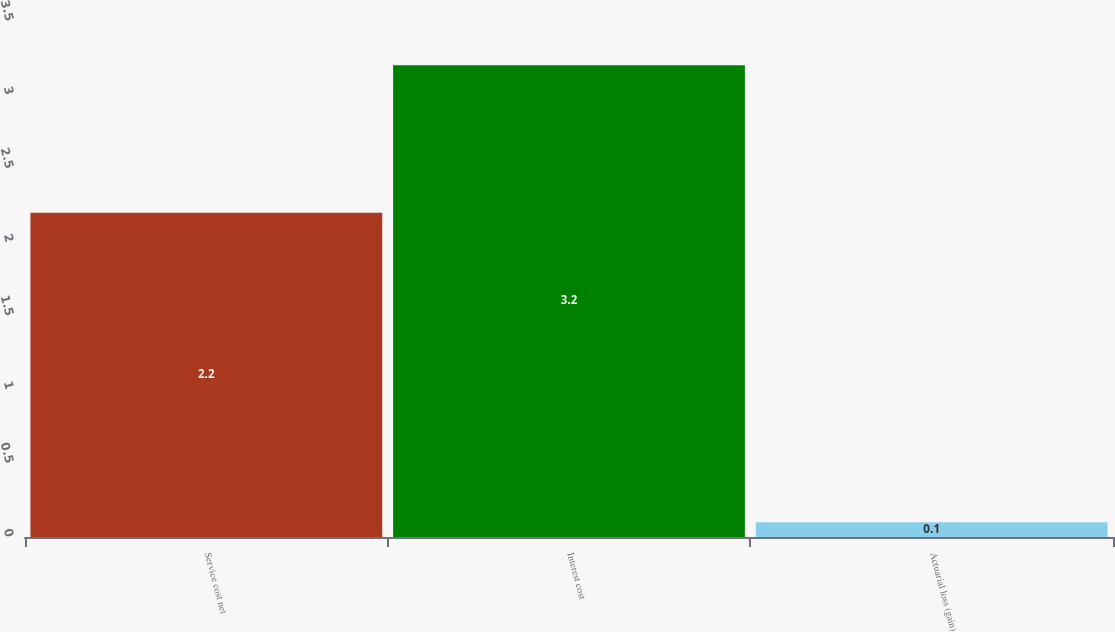Convert chart to OTSL. <chart><loc_0><loc_0><loc_500><loc_500><bar_chart><fcel>Service cost net<fcel>Interest cost<fcel>Actuarial loss (gain)<nl><fcel>2.2<fcel>3.2<fcel>0.1<nl></chart> 